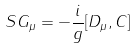<formula> <loc_0><loc_0><loc_500><loc_500>S G _ { \mu } = - \frac { i } { g } [ D _ { \mu } , C ]</formula> 